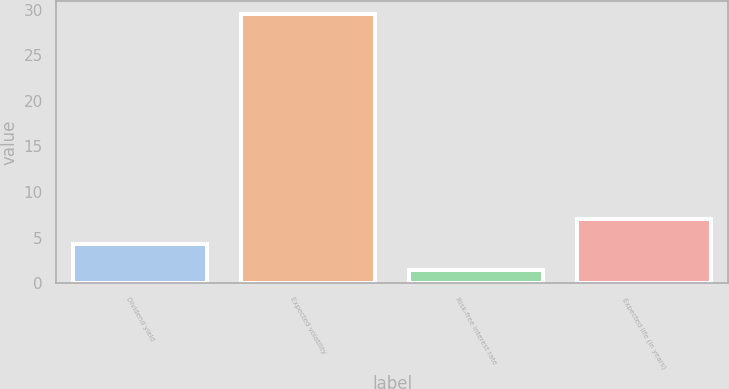<chart> <loc_0><loc_0><loc_500><loc_500><bar_chart><fcel>Dividend yield<fcel>Expected volatility<fcel>Risk-free interest rate<fcel>Expected life (in years)<nl><fcel>4.25<fcel>29.5<fcel>1.44<fcel>7.06<nl></chart> 